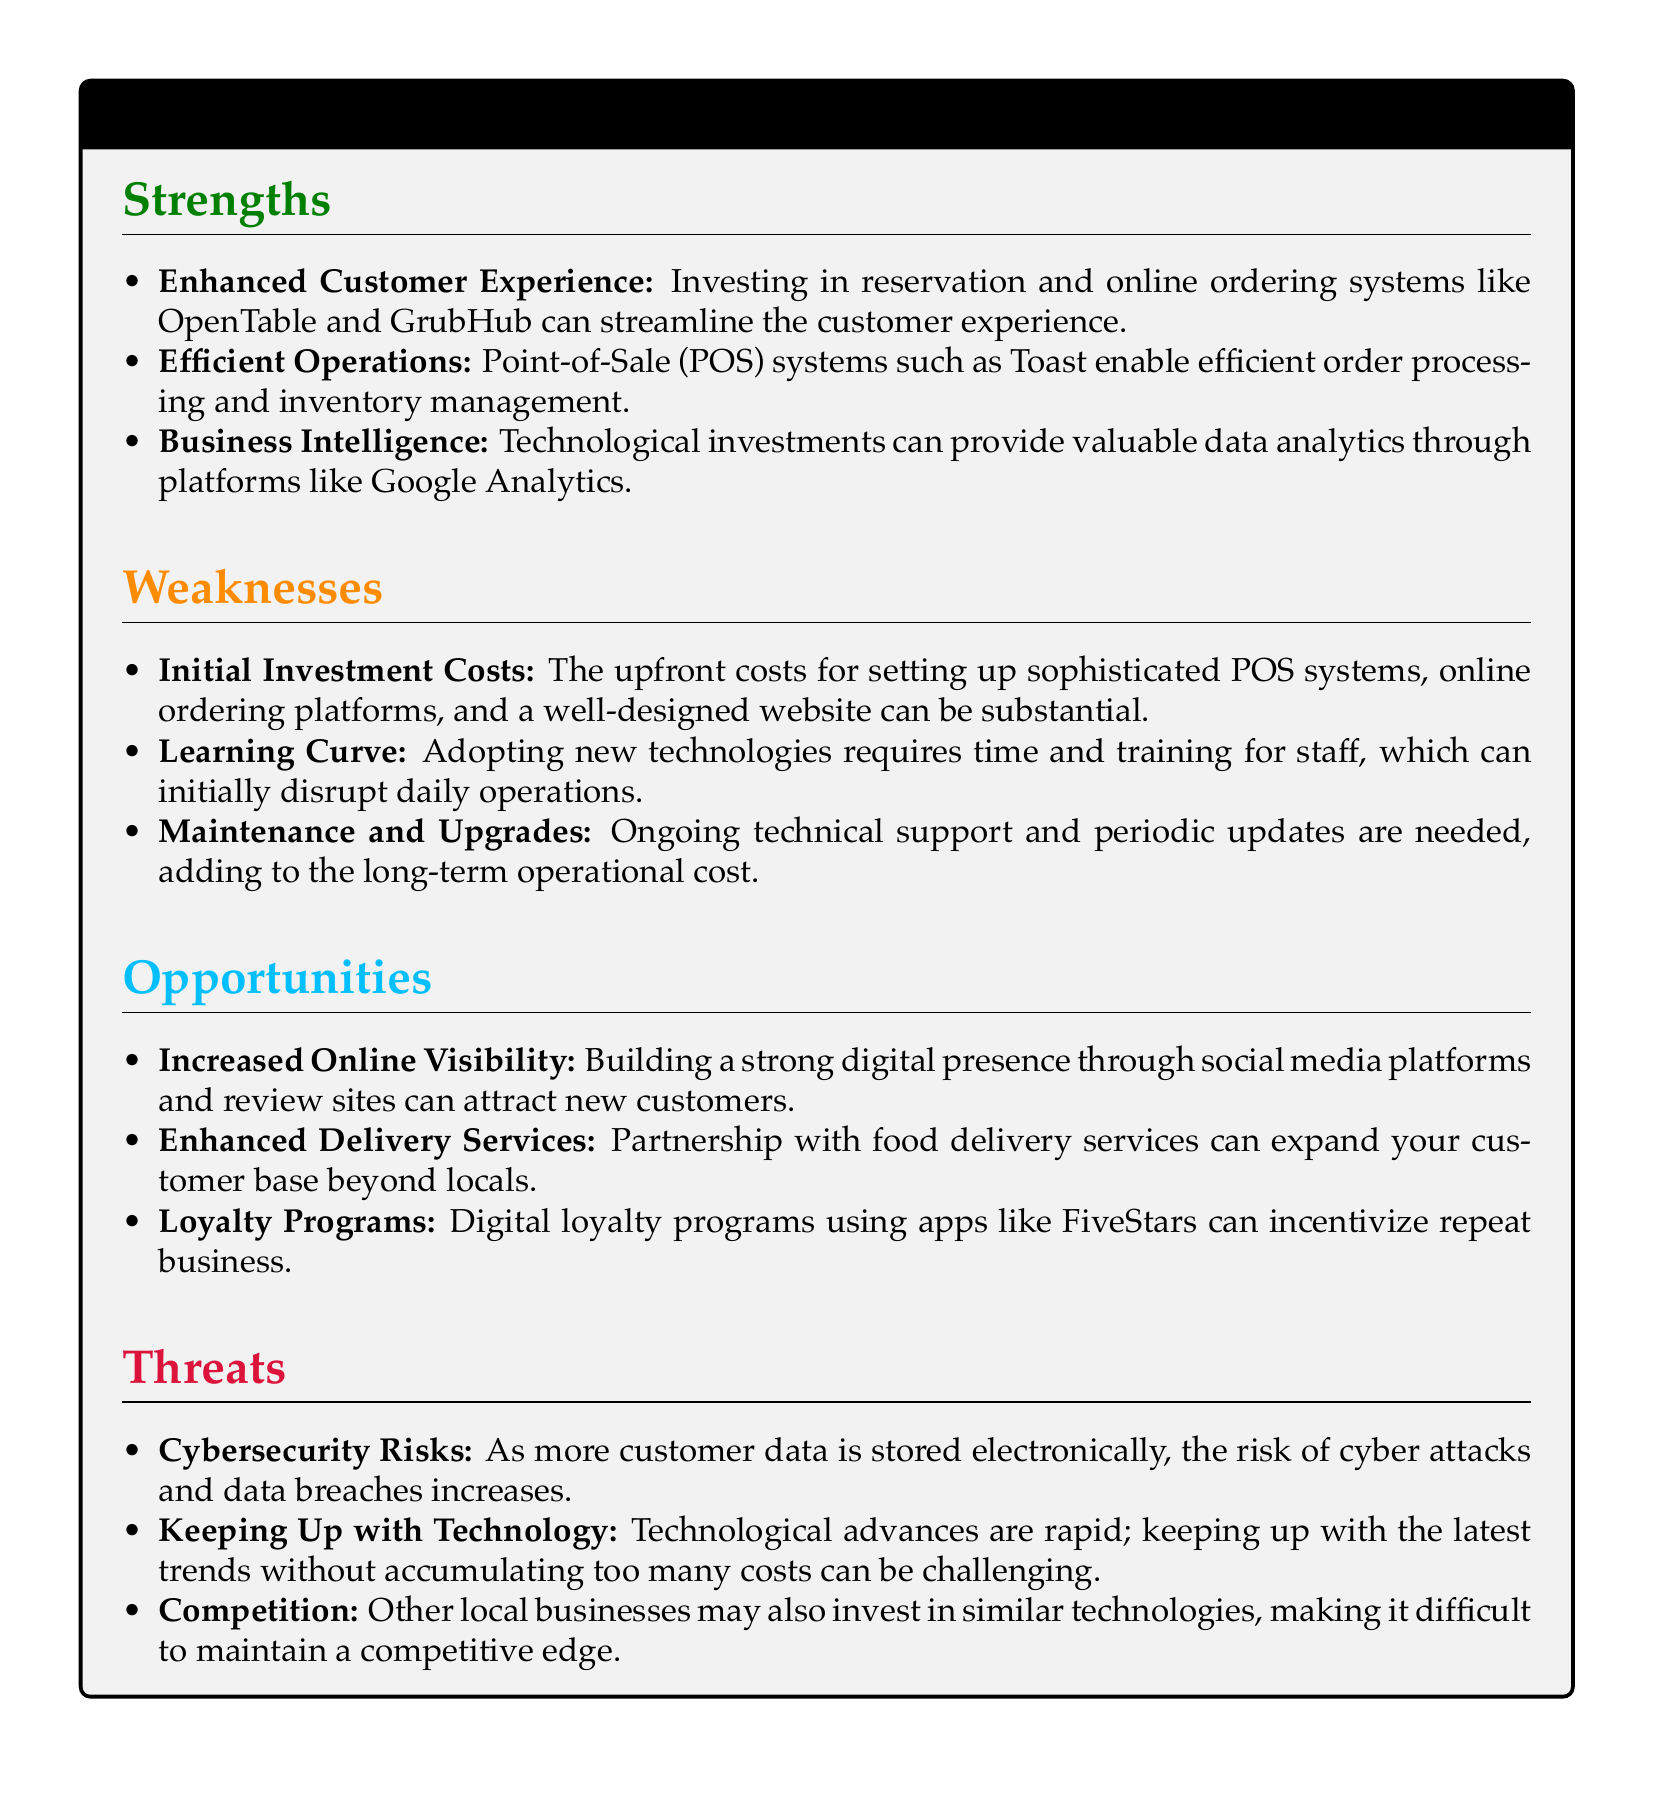What is one strength of technological investments? The document lists enhanced customer experience as a strength that investing in reservation and online ordering systems can bring.
Answer: Enhanced Customer Experience What is a weakness related to initial costs? The document mentions that the upfront costs for setting up sophisticated POS systems can be substantial.
Answer: Initial Investment Costs Which platform is mentioned for valuable data analytics? The document cites Google Analytics as a platform that provides valuable data analytics.
Answer: Google Analytics What is an opportunity for enhancing customer engagement? The document lists digital loyalty programs as an opportunity to incentivize repeat business.
Answer: Loyalty Programs What cybersecurity issue is noted as a threat? The document indicates that the risk of cyber attacks and data breaches increases with more customer data stored electronically.
Answer: Cybersecurity Risks What does the document suggest about competition in technological investments? The document implies that other local businesses may also invest in similar technologies, making it difficult to maintain a competitive edge.
Answer: Competition What is the implication of adopting new technologies according to the weaknesses? The document states that adopting new technologies requires time and training for staff, which can disrupt daily operations.
Answer: Learning Curve How can partnerships enhance service delivery? The document mentions that partnership with food delivery services can expand the customer base beyond locals.
Answer: Enhanced Delivery Services 